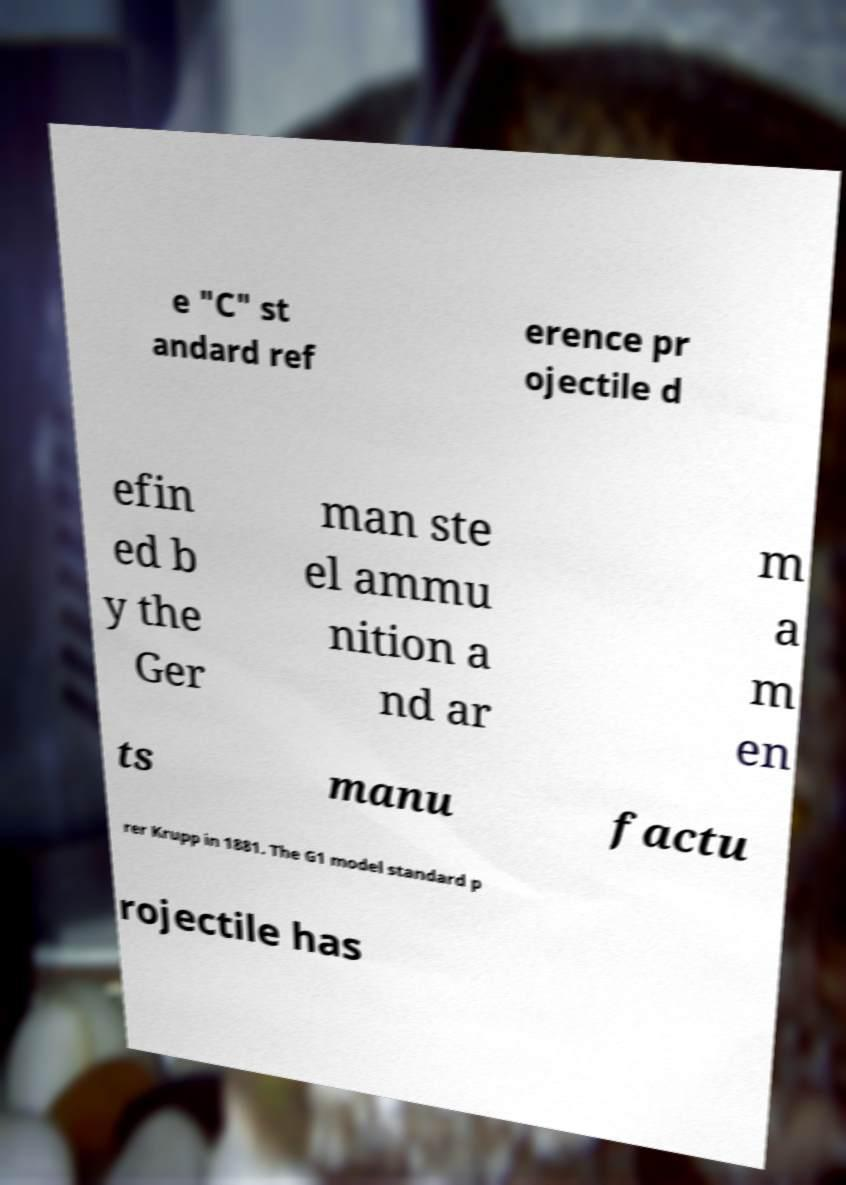Please read and relay the text visible in this image. What does it say? e "C" st andard ref erence pr ojectile d efin ed b y the Ger man ste el ammu nition a nd ar m a m en ts manu factu rer Krupp in 1881. The G1 model standard p rojectile has 